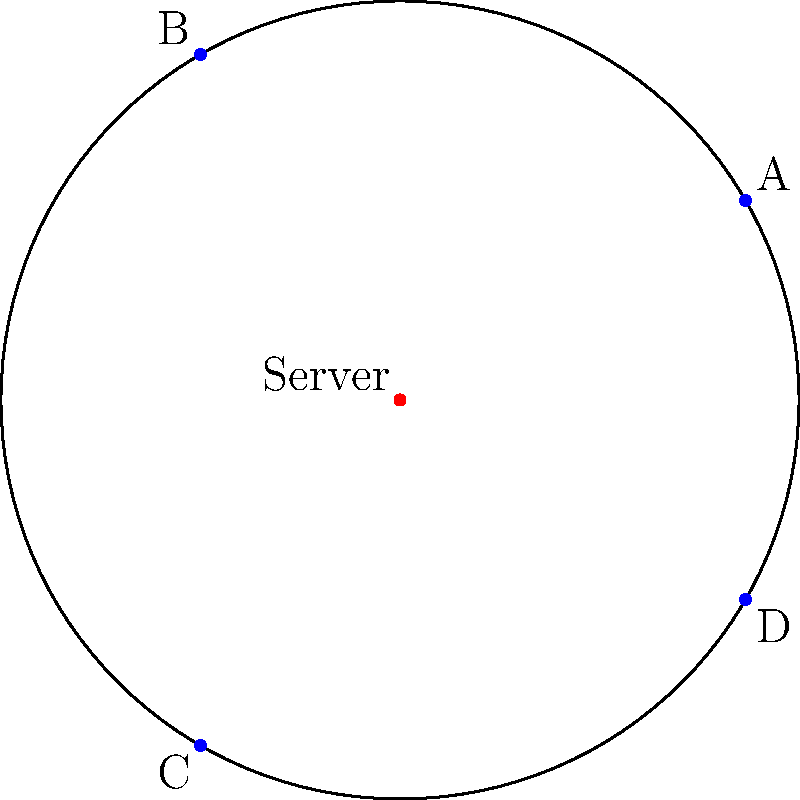In a circular office building, four workstations (A, B, C, and D) are located at different angles around the perimeter. The building has a radius of 10 meters. Workstation A is at 30°, B at 120°, C at 240°, and D at 330°. To minimize network latency, you need to place a central server at a location that minimizes the maximum distance to any workstation. What are the polar coordinates $(r, \theta)$ of the optimal server location? To find the optimal server location, we need to follow these steps:

1) First, we need to understand that the optimal location will be at the center of the smallest circle that encloses all workstations.

2) In this case, due to the symmetry of the workstation locations, the optimal server location will be at the center of the building.

3) To verify this, let's calculate the distances from the center to each workstation:

   For any workstation: $d = 10$ meters (radius of the building)

4) If we move the server from the center, it will get closer to some workstations but farther from others, increasing the maximum distance.

5) Therefore, the center of the building is the optimal location.

6) In polar coordinates, the center is represented as $(0, \theta)$, where $r = 0$ and $\theta$ can be any angle (conventionally, we use 0°).

Thus, the optimal server location in polar coordinates is $(0, 0°)$.
Answer: $(0, 0°)$ 